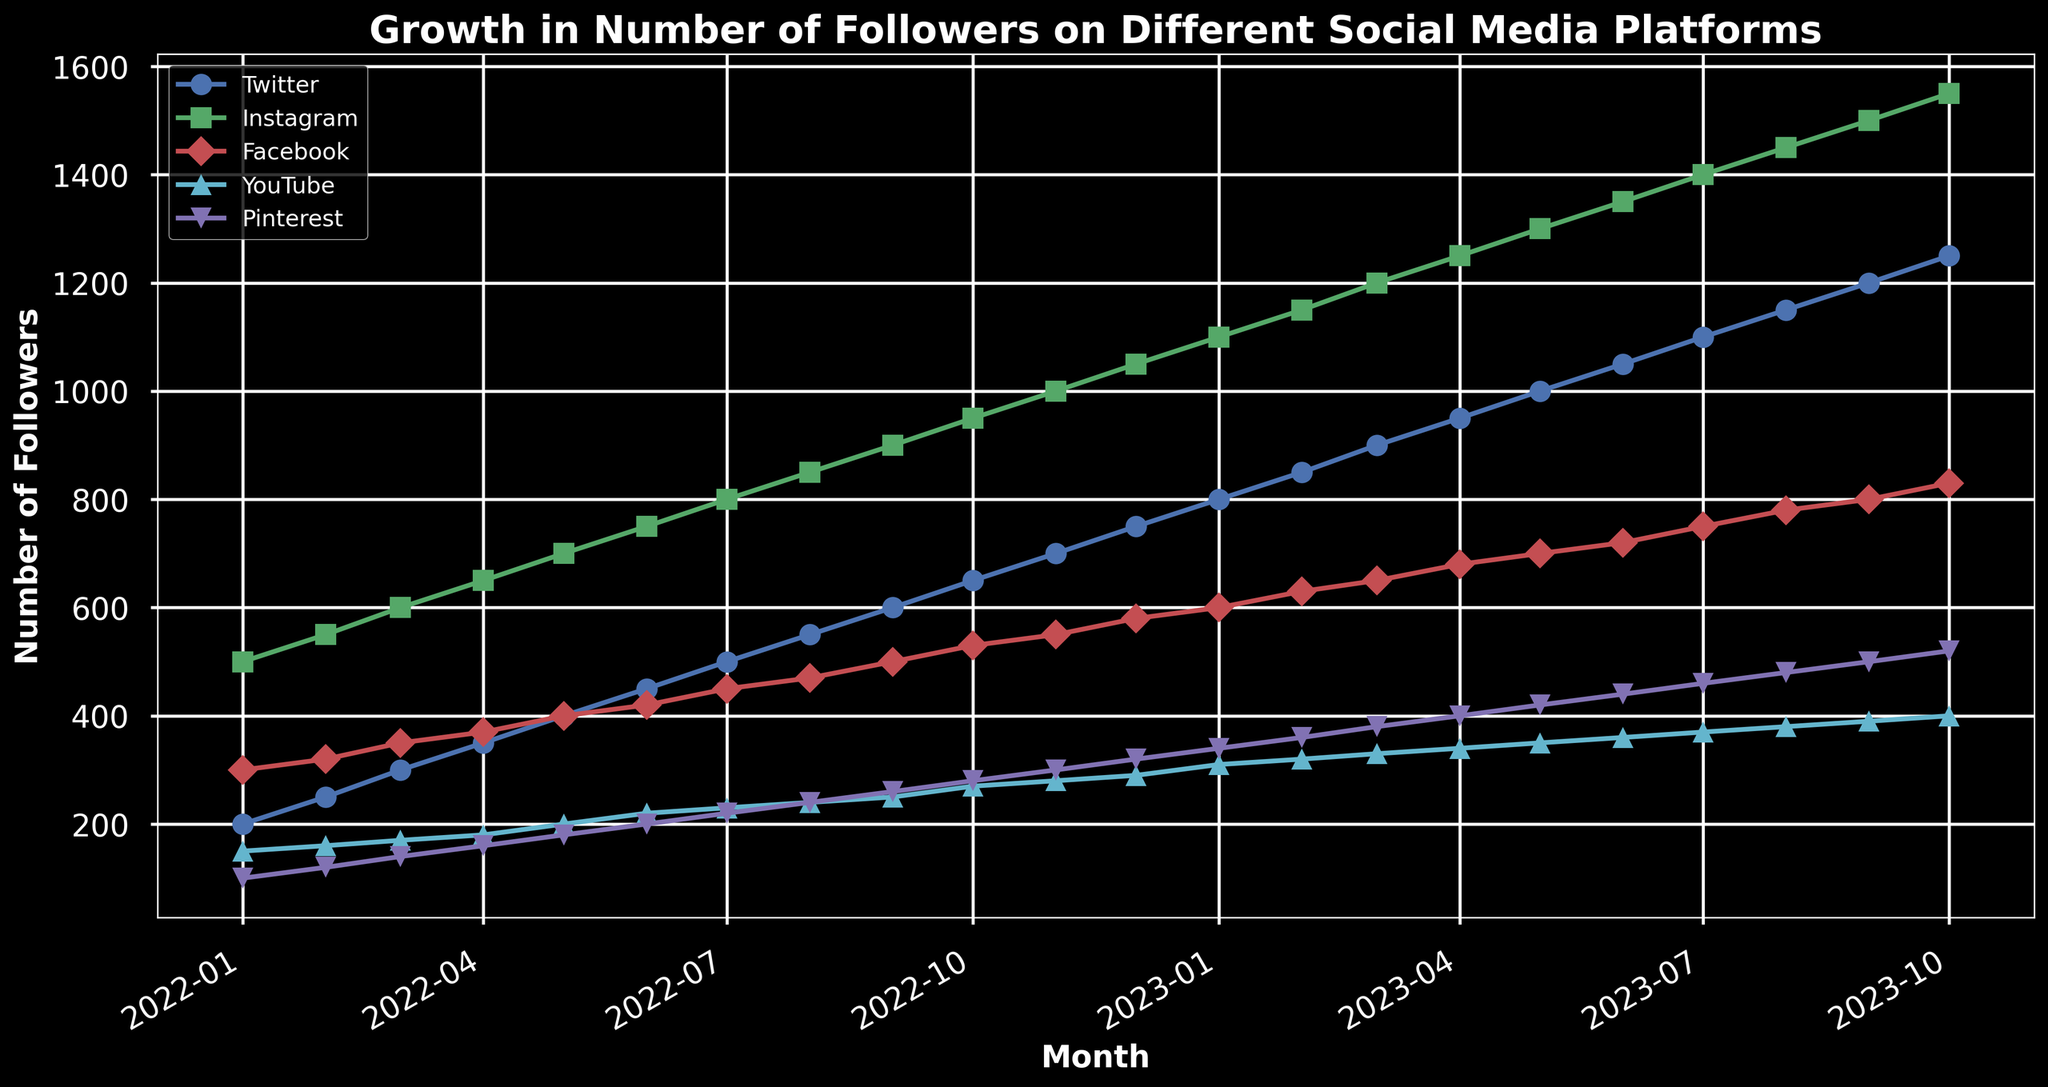What's the trend of follower growth on Instagram from January 2022 to October 2023? To find the trend, observe the Instagram plot line from January 2022 to October 2023. The line steadily increases, moving from 500 followers in January 2022 to 1550 followers in October 2023. This indicates continuous growth over the period.
Answer: Steady growth Which social media platform had the highest number of followers in October 2023? Find the plotted lines at October 2023 and compare their heights. Instagram's line is the highest at 1550 followers compared to others.
Answer: Instagram Between which months did Pinterest see the highest growth in followers? Evaluate the slope of the Pinterest line between each month. The steepest slope is between September 2023 (480) and October 2023 (520), showing 40 followers increase in a month.
Answer: September 2023 to October 2023 What is the difference in the number of followers between Facebook and YouTube in July 2023? Look at the follower counts for Facebook (750) and YouTube (370) in July 2023. Subtract YouTube's count from Facebook's count: 750 - 370.
Answer: 380 Which platform showed the smallest absolute growth over the entire period? Calculate the difference between follower counts from January 2022 to October 2023 for each platform: Twitter (1250 - 200 = 1050), Instagram (1550 - 500 = 1050), Facebook (830 - 300 = 530), YouTube (400 - 150 = 250), Pinterest (520 - 100 = 420). The smallest growth is for YouTube.
Answer: YouTube Which social media platform had equal number of followers in both February 2023 and August 2023? Check the plot lines and their intersections at February 2023 (650) and August 2023 (780). Only Facebook had 650 followers in February 2023 and 780 in August 2023, showing no fluctuation.
Answer: None How does the growth rate of Twitter compare to Pinterest from January 2022 to October 2023? Calculate the growth from January 2022 to October 2023: Twitter (1250-200=1050), Pinterest (520-100=420). Compare the total growth values: 1050 for Twitter vs. 420 for Pinterest. Twitter had a higher growth rate.
Answer: Twitter is higher What was the average number of followers for YouTube in the first quarter of 2023? The first quarter months are January, February, and March 2023. Look at YouTube followers: January (310), February (320), March (330). The average is (310+320+330)/3.
Answer: 320 Which two platforms had the closest follower counts in June 2023? Identify the follower counts for June 2023: Twitter (1050), Instagram (1350), Facebook (720), YouTube (360), Pinterest (440). Compare the differences. The closest are YouTube (360) and Pinterest (440), with a difference of 80.
Answer: YouTube and Pinterest 